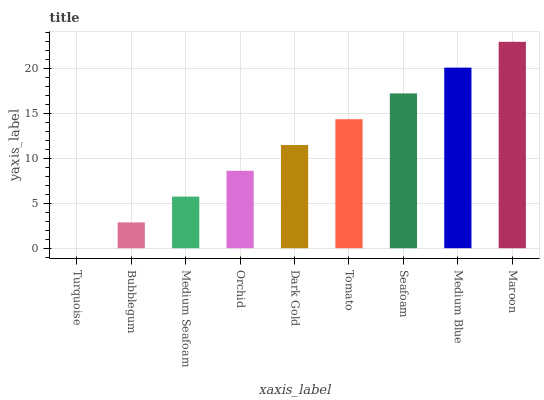Is Turquoise the minimum?
Answer yes or no. Yes. Is Maroon the maximum?
Answer yes or no. Yes. Is Bubblegum the minimum?
Answer yes or no. No. Is Bubblegum the maximum?
Answer yes or no. No. Is Bubblegum greater than Turquoise?
Answer yes or no. Yes. Is Turquoise less than Bubblegum?
Answer yes or no. Yes. Is Turquoise greater than Bubblegum?
Answer yes or no. No. Is Bubblegum less than Turquoise?
Answer yes or no. No. Is Dark Gold the high median?
Answer yes or no. Yes. Is Dark Gold the low median?
Answer yes or no. Yes. Is Bubblegum the high median?
Answer yes or no. No. Is Seafoam the low median?
Answer yes or no. No. 